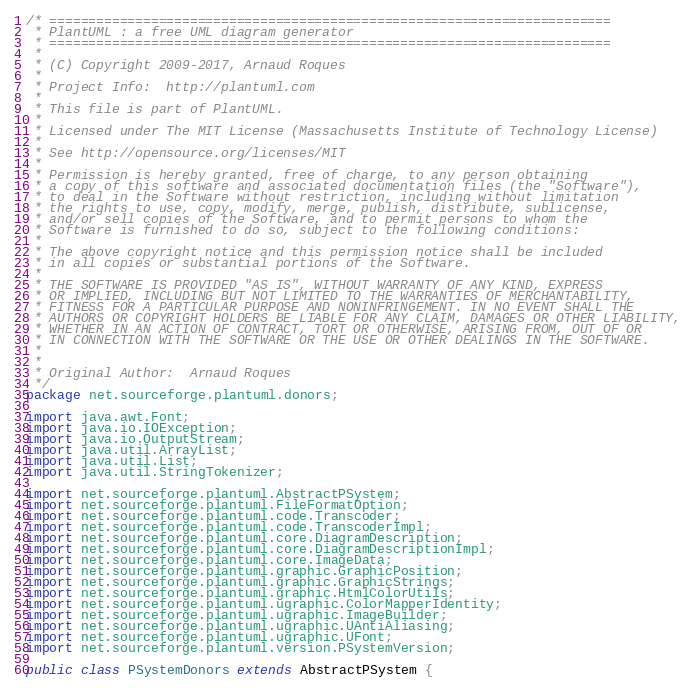Convert code to text. <code><loc_0><loc_0><loc_500><loc_500><_Java_>/* ========================================================================
 * PlantUML : a free UML diagram generator
 * ========================================================================
 *
 * (C) Copyright 2009-2017, Arnaud Roques
 *
 * Project Info:  http://plantuml.com
 * 
 * This file is part of PlantUML.
 *
 * Licensed under The MIT License (Massachusetts Institute of Technology License)
 * 
 * See http://opensource.org/licenses/MIT
 * 
 * Permission is hereby granted, free of charge, to any person obtaining
 * a copy of this software and associated documentation files (the "Software"),
 * to deal in the Software without restriction, including without limitation
 * the rights to use, copy, modify, merge, publish, distribute, sublicense,
 * and/or sell copies of the Software, and to permit persons to whom the
 * Software is furnished to do so, subject to the following conditions:
 * 
 * The above copyright notice and this permission notice shall be included
 * in all copies or substantial portions of the Software.
 * 
 * THE SOFTWARE IS PROVIDED "AS IS", WITHOUT WARRANTY OF ANY KIND, EXPRESS
 * OR IMPLIED, INCLUDING BUT NOT LIMITED TO THE WARRANTIES OF MERCHANTABILITY,
 * FITNESS FOR A PARTICULAR PURPOSE AND NONINFRINGEMENT. IN NO EVENT SHALL THE
 * AUTHORS OR COPYRIGHT HOLDERS BE LIABLE FOR ANY CLAIM, DAMAGES OR OTHER LIABILITY,
 * WHETHER IN AN ACTION OF CONTRACT, TORT OR OTHERWISE, ARISING FROM, OUT OF OR
 * IN CONNECTION WITH THE SOFTWARE OR THE USE OR OTHER DEALINGS IN THE SOFTWARE.
 * 
 *
 * Original Author:  Arnaud Roques
 */
package net.sourceforge.plantuml.donors;

import java.awt.Font;
import java.io.IOException;
import java.io.OutputStream;
import java.util.ArrayList;
import java.util.List;
import java.util.StringTokenizer;

import net.sourceforge.plantuml.AbstractPSystem;
import net.sourceforge.plantuml.FileFormatOption;
import net.sourceforge.plantuml.code.Transcoder;
import net.sourceforge.plantuml.code.TranscoderImpl;
import net.sourceforge.plantuml.core.DiagramDescription;
import net.sourceforge.plantuml.core.DiagramDescriptionImpl;
import net.sourceforge.plantuml.core.ImageData;
import net.sourceforge.plantuml.graphic.GraphicPosition;
import net.sourceforge.plantuml.graphic.GraphicStrings;
import net.sourceforge.plantuml.graphic.HtmlColorUtils;
import net.sourceforge.plantuml.ugraphic.ColorMapperIdentity;
import net.sourceforge.plantuml.ugraphic.ImageBuilder;
import net.sourceforge.plantuml.ugraphic.UAntiAliasing;
import net.sourceforge.plantuml.ugraphic.UFont;
import net.sourceforge.plantuml.version.PSystemVersion;

public class PSystemDonors extends AbstractPSystem {
</code> 